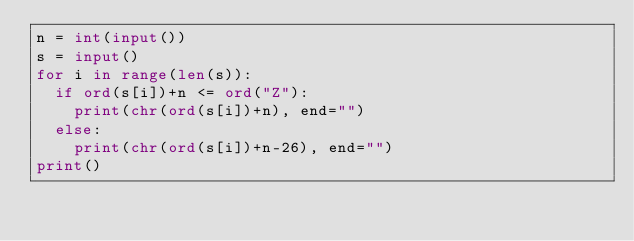<code> <loc_0><loc_0><loc_500><loc_500><_Python_>n = int(input())
s = input()
for i in range(len(s)):
  if ord(s[i])+n <= ord("Z"): 
    print(chr(ord(s[i])+n), end="")
  else:
    print(chr(ord(s[i])+n-26), end="")   
print()</code> 